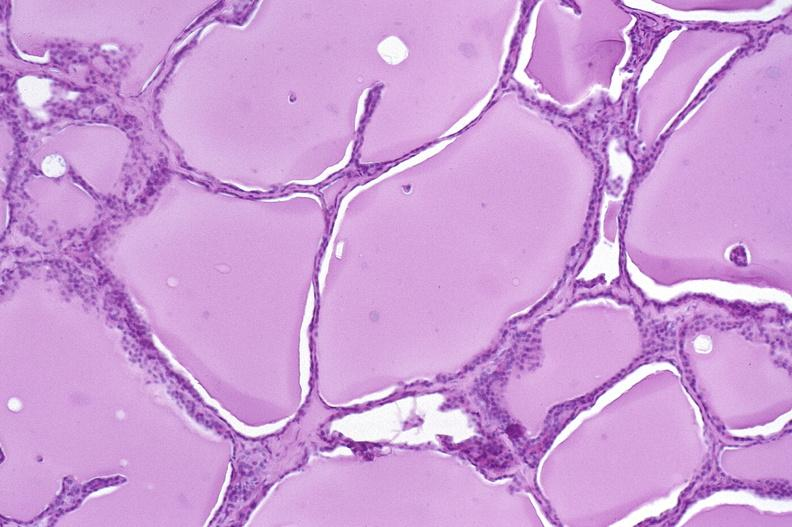does this image show thyroid gland, normal?
Answer the question using a single word or phrase. Yes 